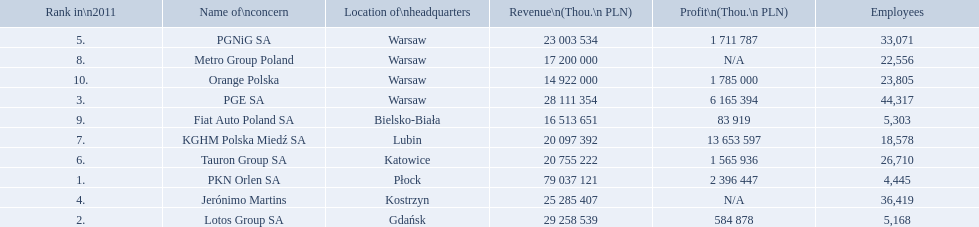What are the names of all the concerns? PKN Orlen SA, Lotos Group SA, PGE SA, Jerónimo Martins, PGNiG SA, Tauron Group SA, KGHM Polska Miedź SA, Metro Group Poland, Fiat Auto Poland SA, Orange Polska. How many employees does pgnig sa have? 33,071. 